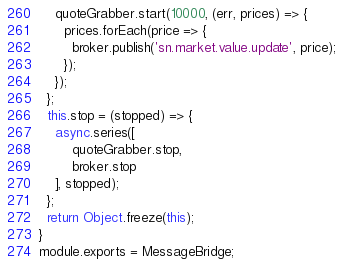Convert code to text. <code><loc_0><loc_0><loc_500><loc_500><_JavaScript_>    quoteGrabber.start(10000, (err, prices) => {
      prices.forEach(price => {
        broker.publish('sn.market.value.update', price);
      });
    });
  };
  this.stop = (stopped) => {
    async.series([
        quoteGrabber.stop,
        broker.stop
    ], stopped);
  };
  return Object.freeze(this);
}
module.exports = MessageBridge;
</code> 